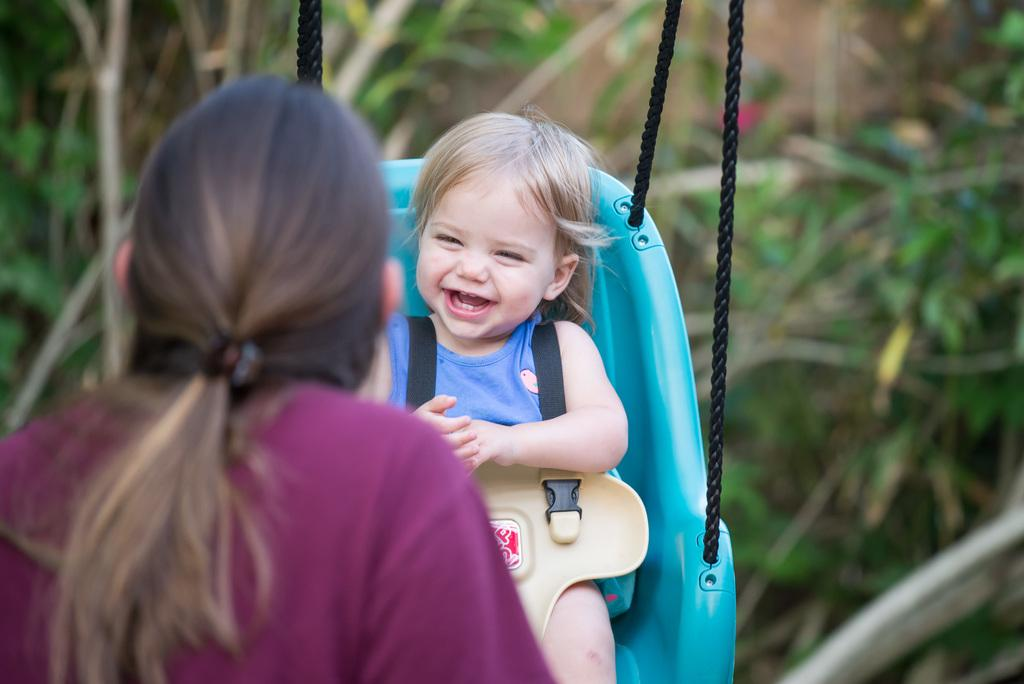What is the main subject of the image? The main subject of the image is a kid. What is the kid doing in the image? The kid is sitting on a swing. Who is present with the kid in the image? There is a woman in front of the kid. What can be seen in the background of the image? There are blurred plants behind the kid. What type of list can be seen in the image? There is no list present in the image. What kind of zephyr is blowing through the image? There is no mention of a zephyr in the image, and it is not visible. 